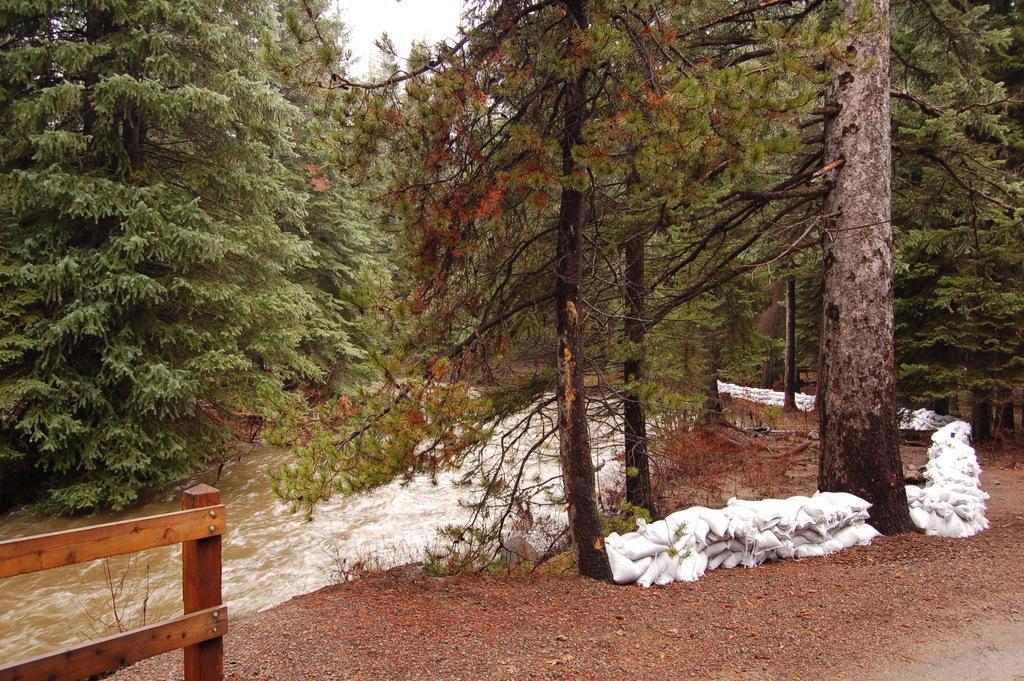In one or two sentences, can you explain what this image depicts? In this picture we can see trees, there is water in the middle, at the bottom there are some stones, on the right side we can see bags, there is the sky at the top of the picture. 